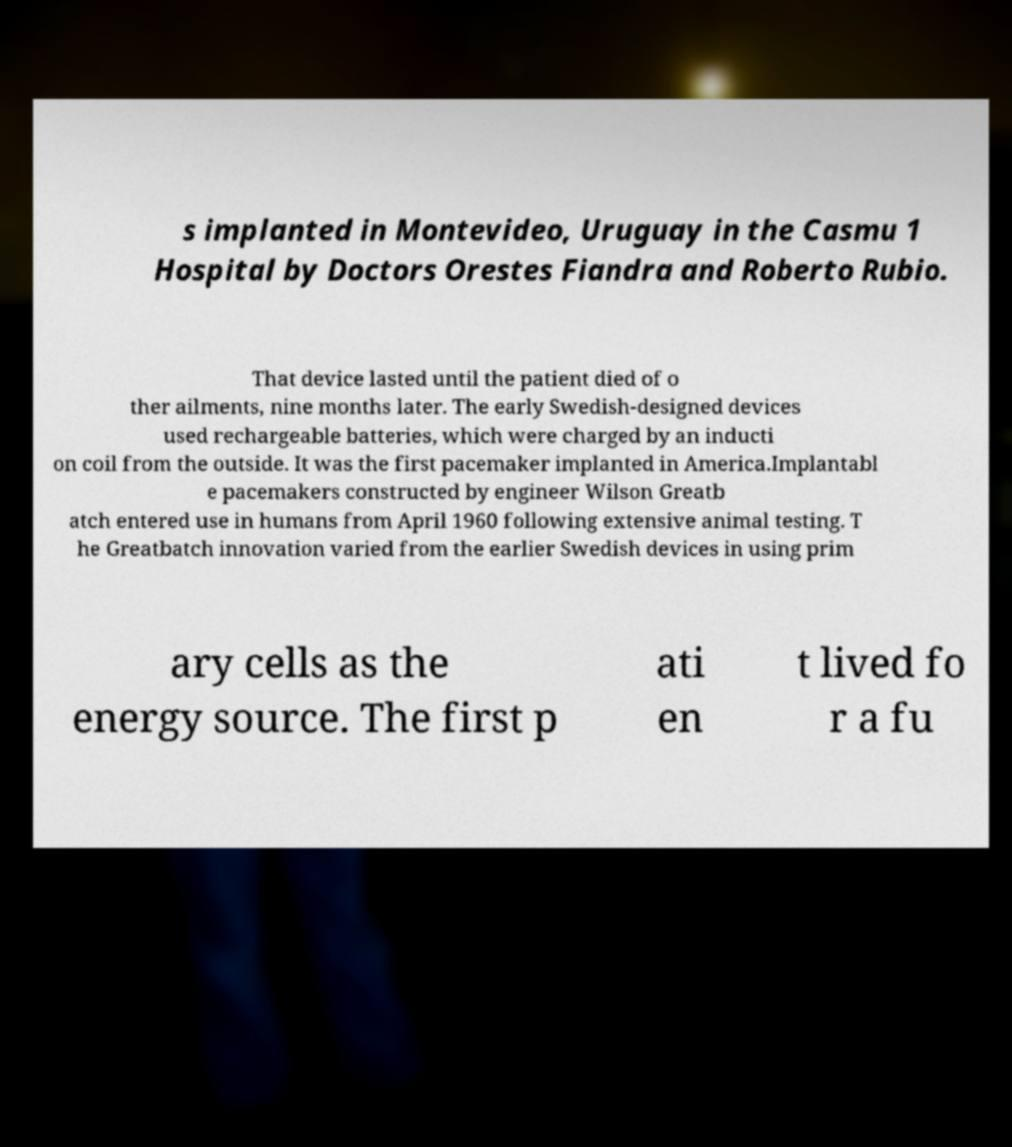Could you assist in decoding the text presented in this image and type it out clearly? s implanted in Montevideo, Uruguay in the Casmu 1 Hospital by Doctors Orestes Fiandra and Roberto Rubio. That device lasted until the patient died of o ther ailments, nine months later. The early Swedish-designed devices used rechargeable batteries, which were charged by an inducti on coil from the outside. It was the first pacemaker implanted in America.Implantabl e pacemakers constructed by engineer Wilson Greatb atch entered use in humans from April 1960 following extensive animal testing. T he Greatbatch innovation varied from the earlier Swedish devices in using prim ary cells as the energy source. The first p ati en t lived fo r a fu 